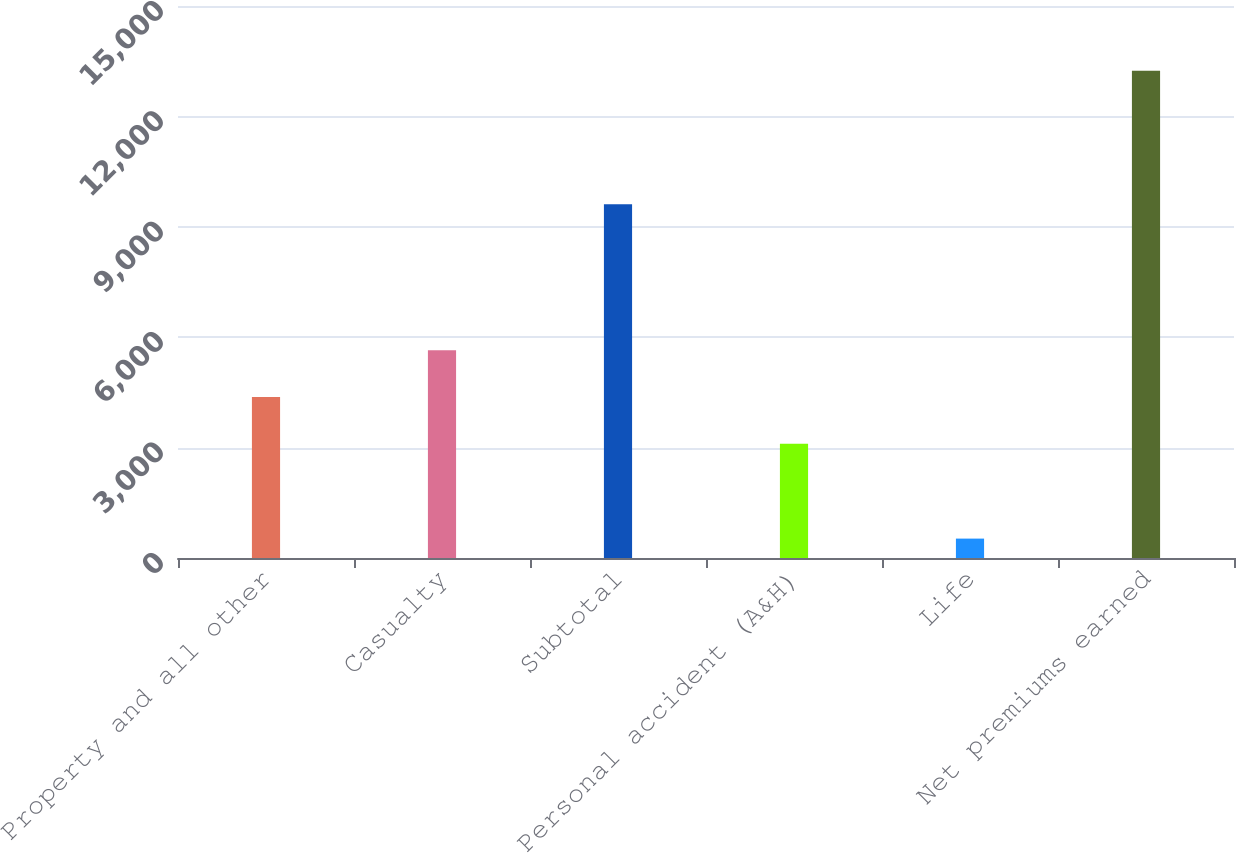Convert chart to OTSL. <chart><loc_0><loc_0><loc_500><loc_500><bar_chart><fcel>Property and all other<fcel>Casualty<fcel>Subtotal<fcel>Personal accident (A&H)<fcel>Life<fcel>Net premiums earned<nl><fcel>4374.3<fcel>5645.6<fcel>9610<fcel>3103<fcel>527<fcel>13240<nl></chart> 